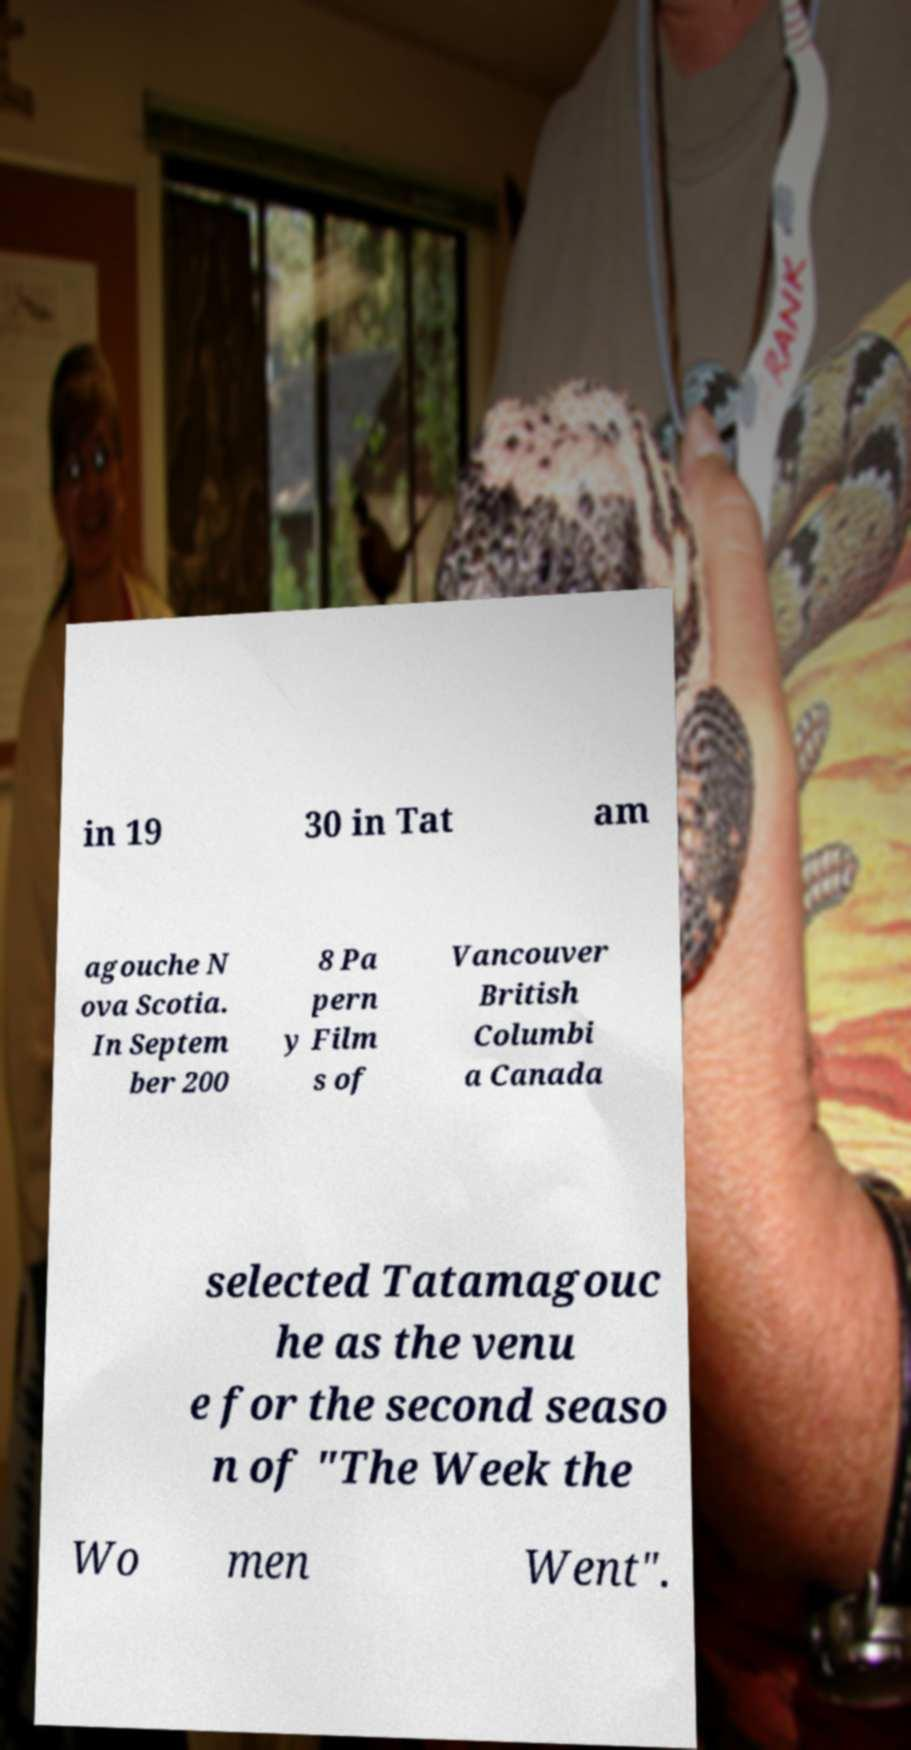Can you accurately transcribe the text from the provided image for me? in 19 30 in Tat am agouche N ova Scotia. In Septem ber 200 8 Pa pern y Film s of Vancouver British Columbi a Canada selected Tatamagouc he as the venu e for the second seaso n of "The Week the Wo men Went". 